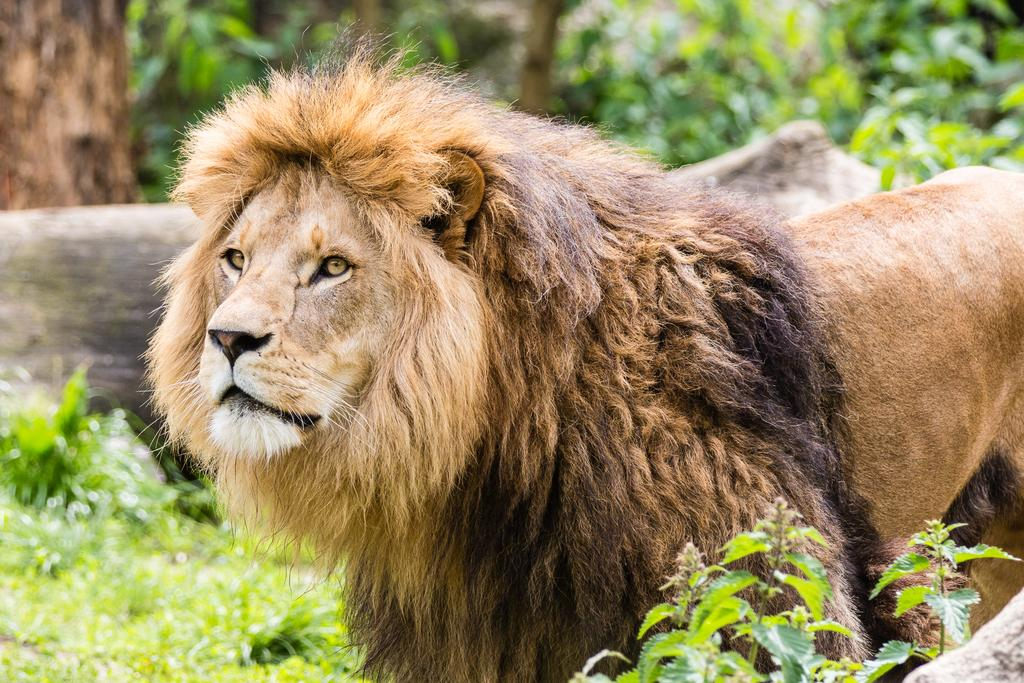What animal is standing in the front of the image? There is a lion standing in the front of the image. What type of vegetation is at the bottom of the image? There are plants at the bottom of the image. What material can be seen in the background of the image? There is wood visible in the background of the image. What type of natural feature is visible in the background of the image? There are trees in the background of the image. How many potatoes are visible in the image? There are no potatoes present in the image. What type of insect can be seen interacting with the lion in the image? There are no insects visible in the image, and the lion is not interacting with any insects. 